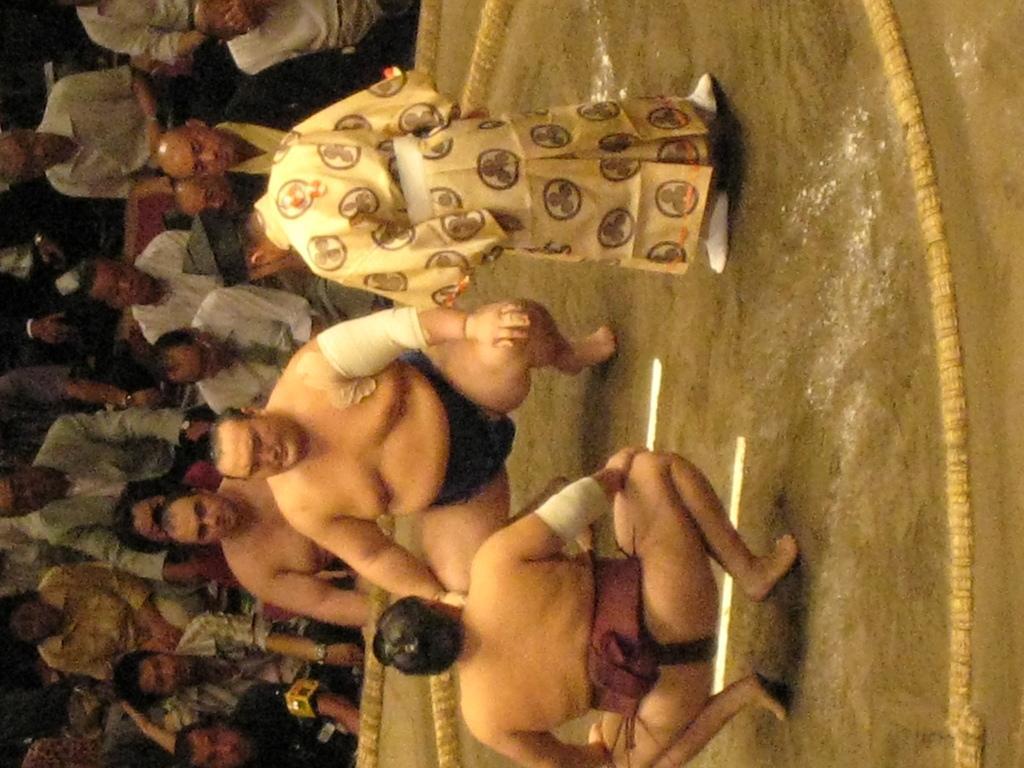Please provide a concise description of this image. In this picture there are two people in the foreground might be squatting and there is a person standing. At the back there are group of people sitting. At the bottom there is a rope on the floor. 